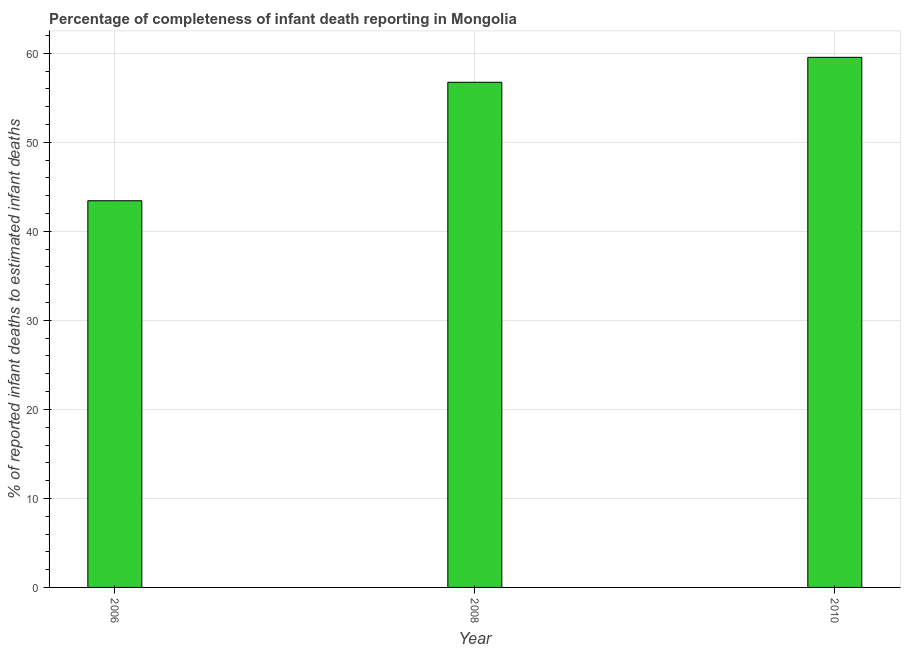What is the title of the graph?
Offer a terse response. Percentage of completeness of infant death reporting in Mongolia. What is the label or title of the Y-axis?
Keep it short and to the point. % of reported infant deaths to estimated infant deaths. What is the completeness of infant death reporting in 2006?
Offer a terse response. 43.44. Across all years, what is the maximum completeness of infant death reporting?
Make the answer very short. 59.55. Across all years, what is the minimum completeness of infant death reporting?
Keep it short and to the point. 43.44. In which year was the completeness of infant death reporting maximum?
Offer a very short reply. 2010. What is the sum of the completeness of infant death reporting?
Provide a short and direct response. 159.74. What is the difference between the completeness of infant death reporting in 2006 and 2010?
Ensure brevity in your answer.  -16.11. What is the average completeness of infant death reporting per year?
Give a very brief answer. 53.25. What is the median completeness of infant death reporting?
Your response must be concise. 56.75. In how many years, is the completeness of infant death reporting greater than 58 %?
Ensure brevity in your answer.  1. What is the ratio of the completeness of infant death reporting in 2008 to that in 2010?
Ensure brevity in your answer.  0.95. Is the completeness of infant death reporting in 2006 less than that in 2010?
Make the answer very short. Yes. Is the difference between the completeness of infant death reporting in 2006 and 2008 greater than the difference between any two years?
Keep it short and to the point. No. What is the difference between the highest and the second highest completeness of infant death reporting?
Give a very brief answer. 2.8. What is the difference between the highest and the lowest completeness of infant death reporting?
Keep it short and to the point. 16.11. In how many years, is the completeness of infant death reporting greater than the average completeness of infant death reporting taken over all years?
Offer a terse response. 2. How many bars are there?
Offer a very short reply. 3. Are all the bars in the graph horizontal?
Offer a terse response. No. Are the values on the major ticks of Y-axis written in scientific E-notation?
Make the answer very short. No. What is the % of reported infant deaths to estimated infant deaths in 2006?
Give a very brief answer. 43.44. What is the % of reported infant deaths to estimated infant deaths in 2008?
Provide a succinct answer. 56.75. What is the % of reported infant deaths to estimated infant deaths in 2010?
Make the answer very short. 59.55. What is the difference between the % of reported infant deaths to estimated infant deaths in 2006 and 2008?
Offer a very short reply. -13.31. What is the difference between the % of reported infant deaths to estimated infant deaths in 2006 and 2010?
Make the answer very short. -16.11. What is the difference between the % of reported infant deaths to estimated infant deaths in 2008 and 2010?
Provide a succinct answer. -2.8. What is the ratio of the % of reported infant deaths to estimated infant deaths in 2006 to that in 2008?
Offer a very short reply. 0.77. What is the ratio of the % of reported infant deaths to estimated infant deaths in 2006 to that in 2010?
Make the answer very short. 0.73. What is the ratio of the % of reported infant deaths to estimated infant deaths in 2008 to that in 2010?
Offer a terse response. 0.95. 